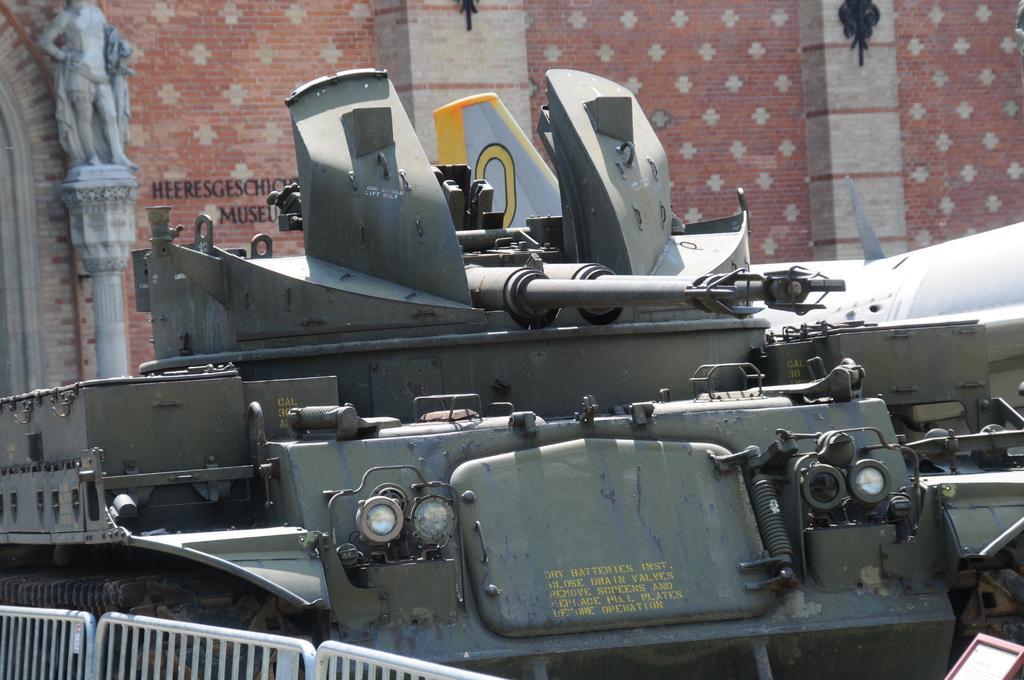Could you give a brief overview of what you see in this image? In this image I can see a vehicle. Background I can see a wall in cream and lite brown color. 